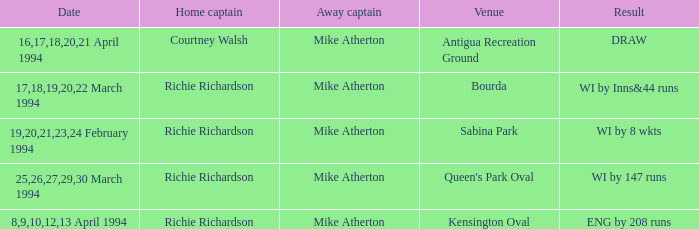When did a Venue of Antigua Recreation Ground happen? 16,17,18,20,21 April 1994. 